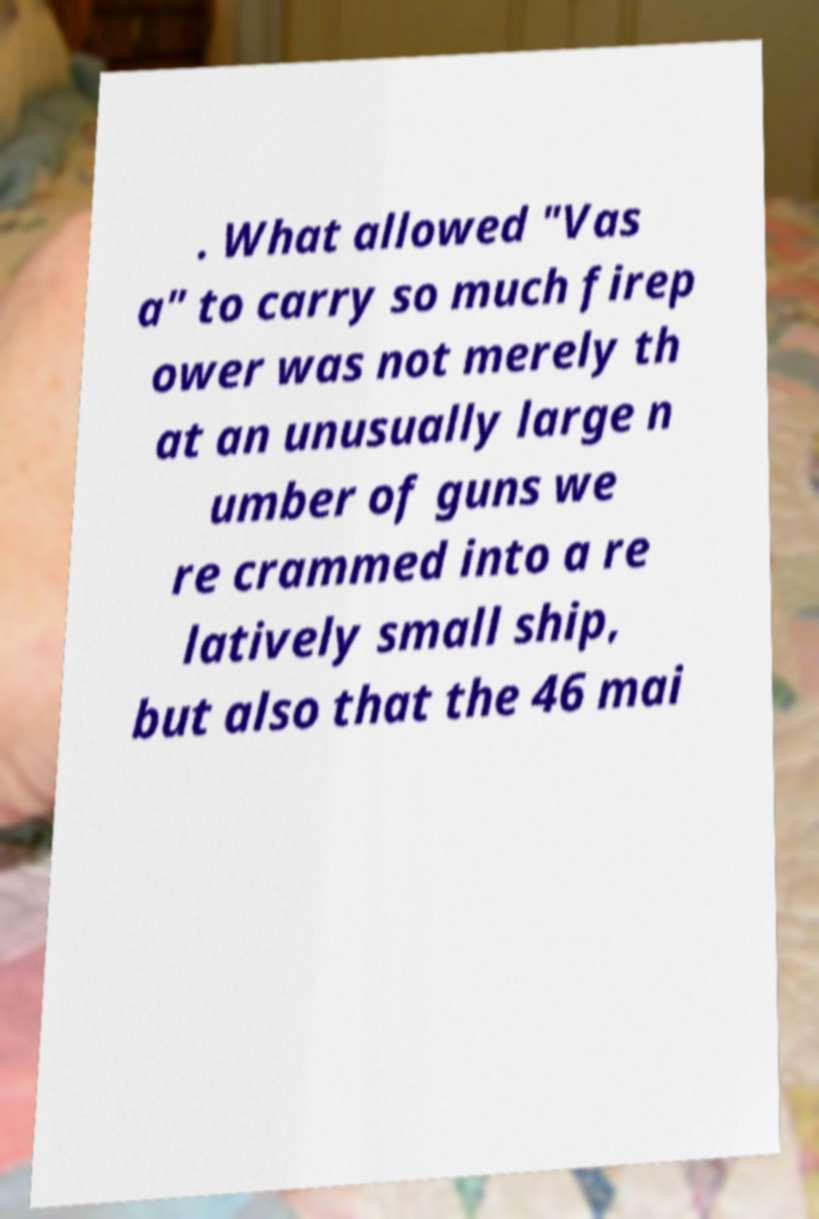Can you accurately transcribe the text from the provided image for me? . What allowed "Vas a" to carry so much firep ower was not merely th at an unusually large n umber of guns we re crammed into a re latively small ship, but also that the 46 mai 